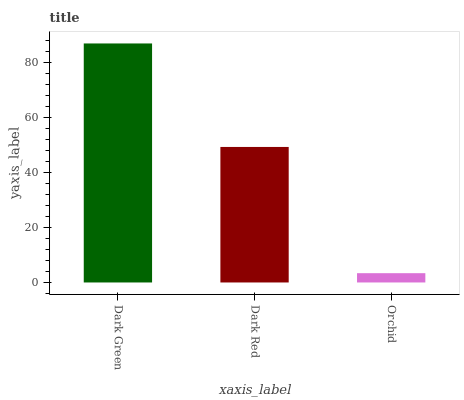Is Orchid the minimum?
Answer yes or no. Yes. Is Dark Green the maximum?
Answer yes or no. Yes. Is Dark Red the minimum?
Answer yes or no. No. Is Dark Red the maximum?
Answer yes or no. No. Is Dark Green greater than Dark Red?
Answer yes or no. Yes. Is Dark Red less than Dark Green?
Answer yes or no. Yes. Is Dark Red greater than Dark Green?
Answer yes or no. No. Is Dark Green less than Dark Red?
Answer yes or no. No. Is Dark Red the high median?
Answer yes or no. Yes. Is Dark Red the low median?
Answer yes or no. Yes. Is Orchid the high median?
Answer yes or no. No. Is Orchid the low median?
Answer yes or no. No. 